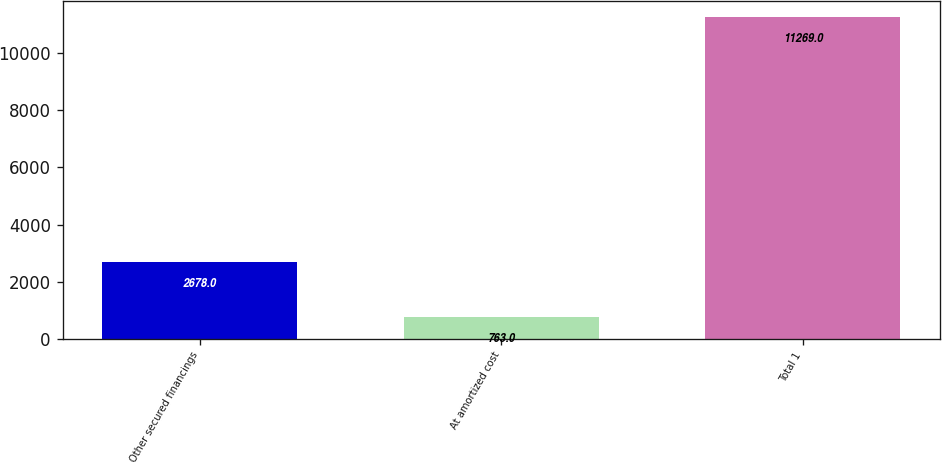<chart> <loc_0><loc_0><loc_500><loc_500><bar_chart><fcel>Other secured financings<fcel>At amortized cost<fcel>Total 1<nl><fcel>2678<fcel>763<fcel>11269<nl></chart> 